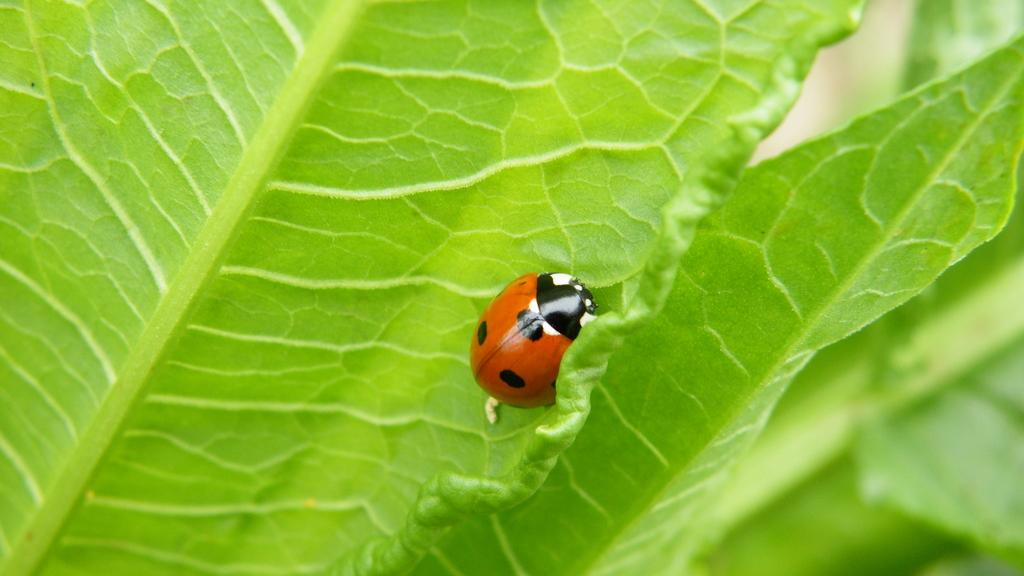What type of insect is in the image? There is a beetle in the image. Where is the beetle located? The beetle is on a leaf. What type of guitar is the crook playing in the image? There is no crook or guitar present in the image; it only features a beetle on a leaf. 